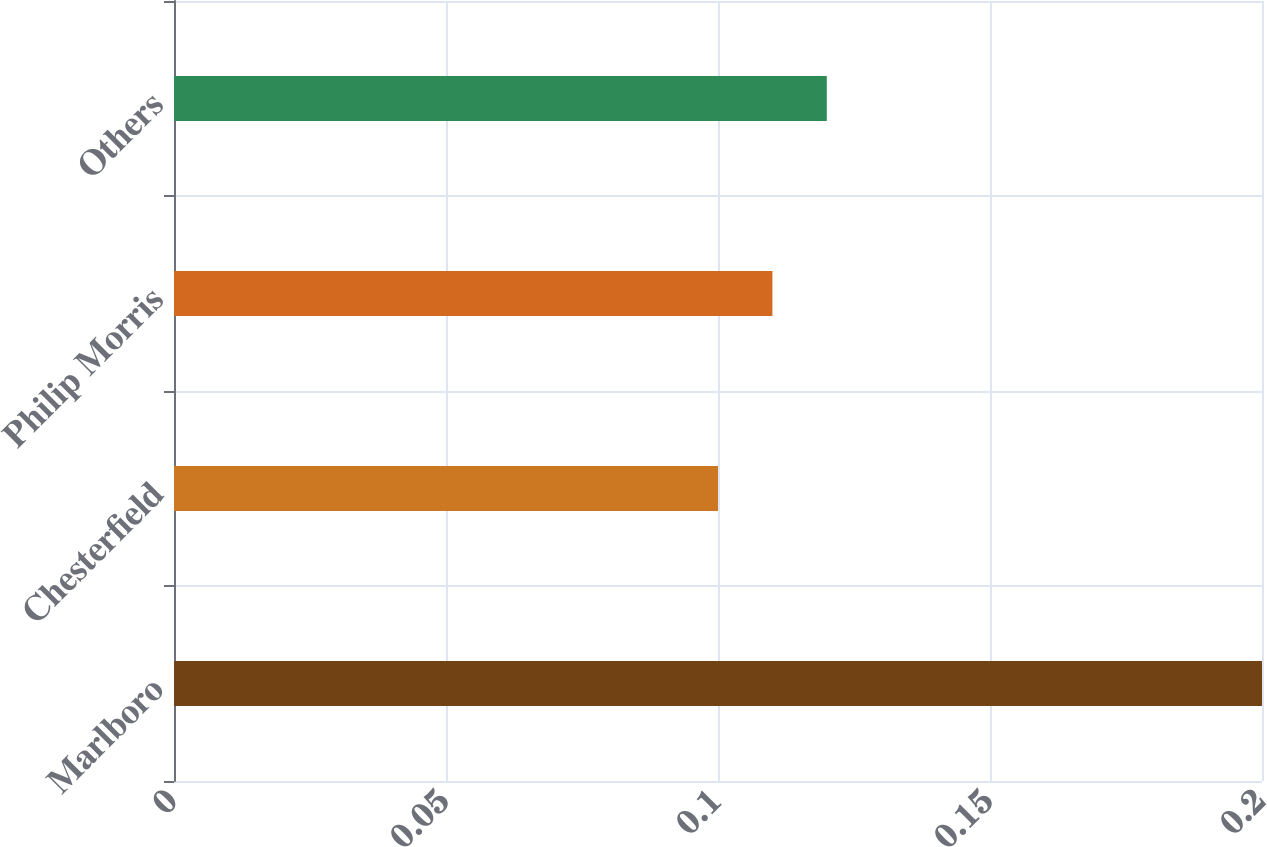<chart> <loc_0><loc_0><loc_500><loc_500><bar_chart><fcel>Marlboro<fcel>Chesterfield<fcel>Philip Morris<fcel>Others<nl><fcel>0.2<fcel>0.1<fcel>0.11<fcel>0.12<nl></chart> 